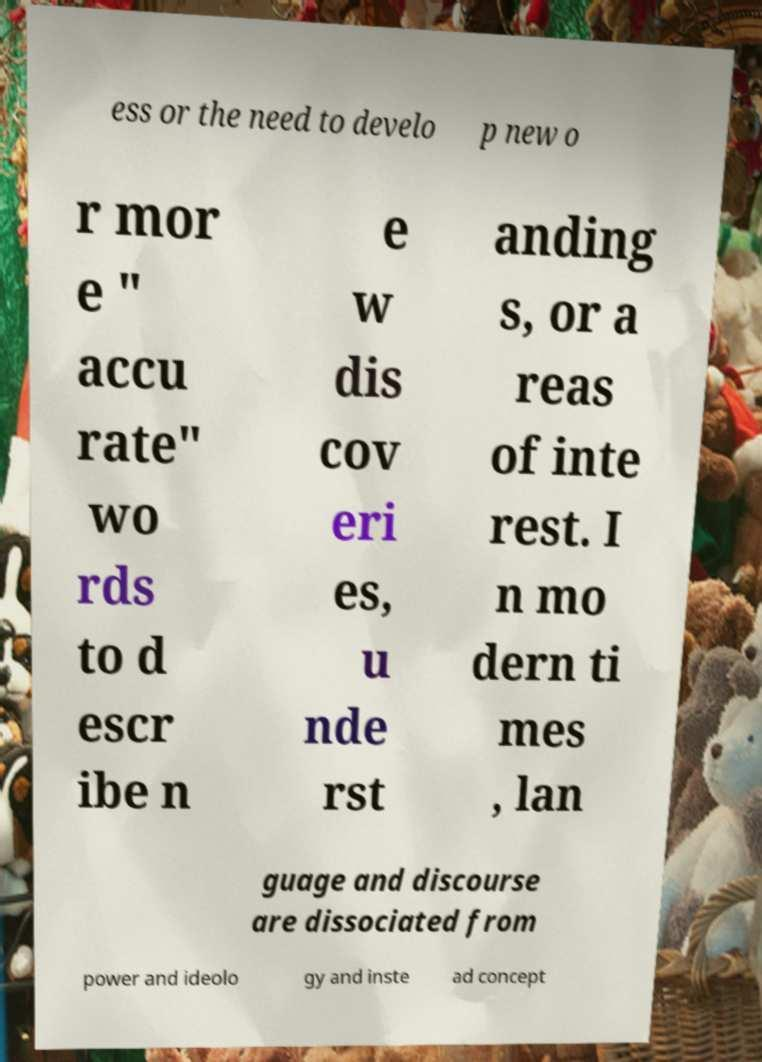There's text embedded in this image that I need extracted. Can you transcribe it verbatim? ess or the need to develo p new o r mor e " accu rate" wo rds to d escr ibe n e w dis cov eri es, u nde rst anding s, or a reas of inte rest. I n mo dern ti mes , lan guage and discourse are dissociated from power and ideolo gy and inste ad concept 